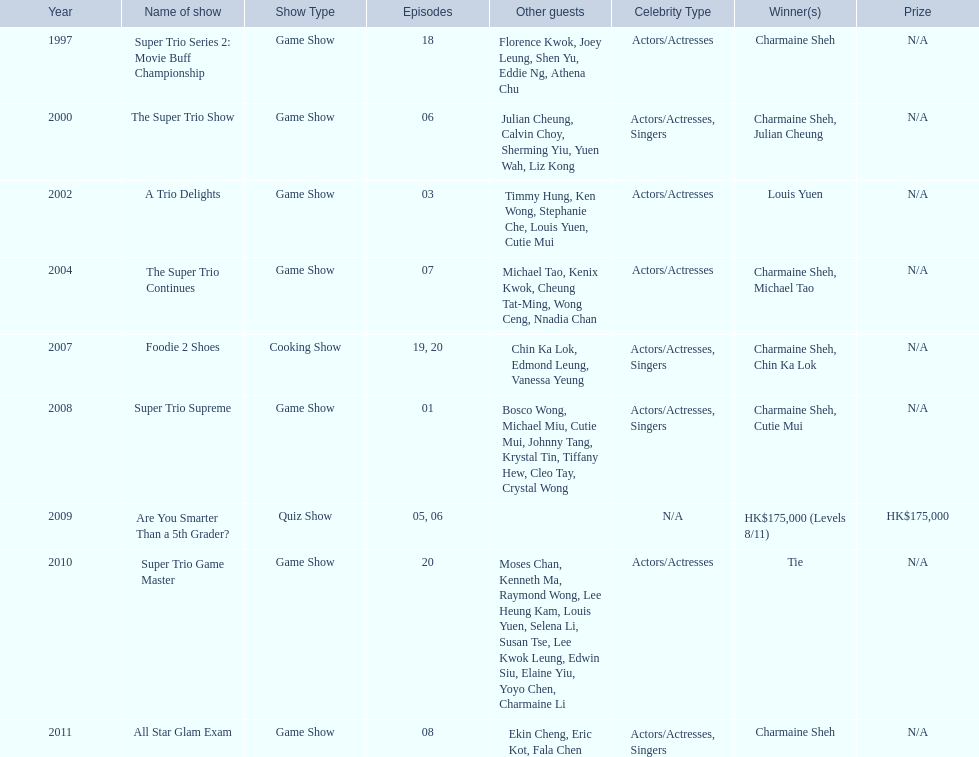How many times has charmaine sheh won on a variety show? 6. 